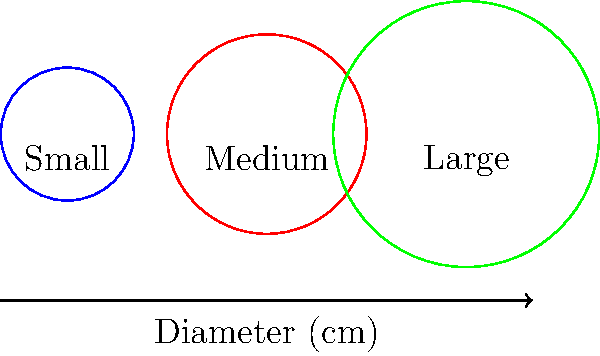As a freelance writer who frequents coffee shops, you've noticed three sizes of circular coffee cups: small, medium, and large. The barista mentions that the diameters of these cups are 2 cm, 3 cm, and 4 cm respectively. If you were to trace the rim of each cup, what would be the total length of the combined circumferences? Round your answer to the nearest centimeter. To solve this problem, we'll follow these steps:

1) Recall the formula for the circumference of a circle: $C = \pi d$, where $d$ is the diameter.

2) Calculate the circumference of each cup:

   Small cup:  $C_s = \pi \times 2 = 2\pi$ cm
   Medium cup: $C_m = \pi \times 3 = 3\pi$ cm
   Large cup:  $C_l = \pi \times 4 = 4\pi$ cm

3) Sum up all three circumferences:

   $C_{total} = C_s + C_m + C_l = 2\pi + 3\pi + 4\pi = 9\pi$ cm

4) Calculate the numerical value (using $\pi \approx 3.14159$):

   $C_{total} \approx 9 \times 3.14159 \approx 28.27431$ cm

5) Round to the nearest centimeter:

   $C_{total} \approx 28$ cm

Therefore, the total length of the combined circumferences is approximately 28 cm.
Answer: 28 cm 